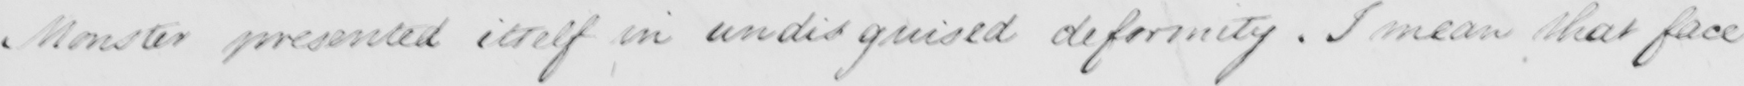Can you read and transcribe this handwriting? Monster presented itself in undisguised deformity . I mean that face 